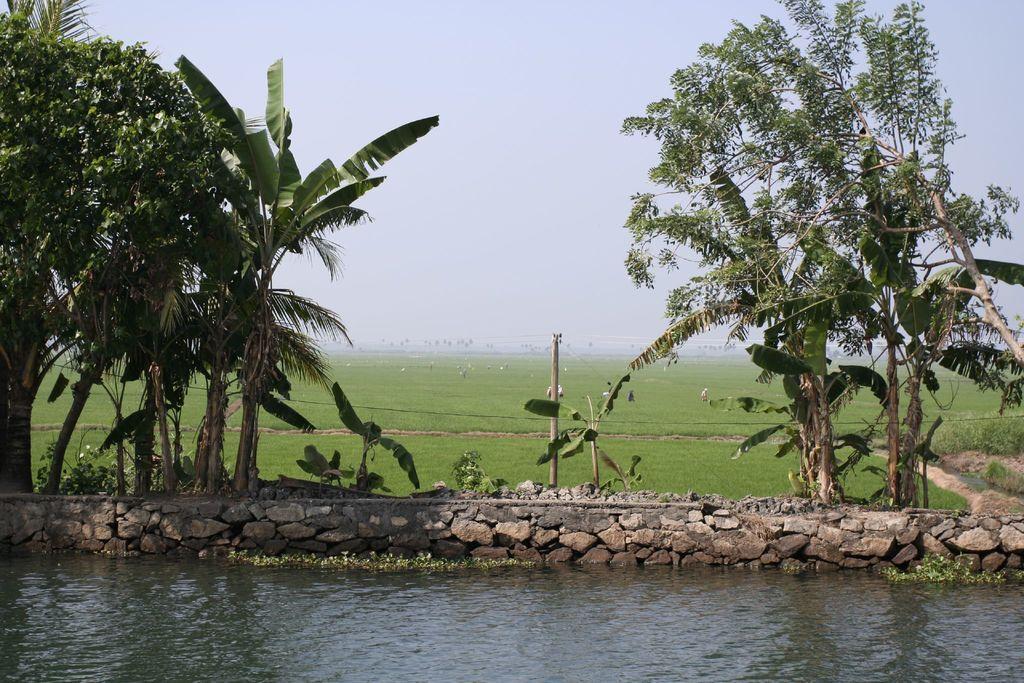Could you give a brief overview of what you see in this image? In this picture I can see water, there are few people, there are trees, and in the background there is the sky. 